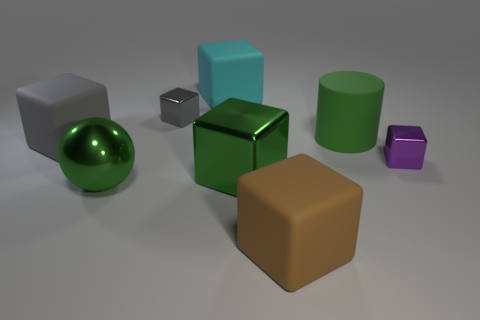Subtract all small purple cubes. How many cubes are left? 5 Add 2 yellow cubes. How many objects exist? 10 Subtract all gray blocks. How many blocks are left? 4 Subtract 4 cubes. How many cubes are left? 2 Subtract all red spheres. How many gray blocks are left? 2 Add 7 shiny balls. How many shiny balls are left? 8 Add 6 small purple metallic blocks. How many small purple metallic blocks exist? 7 Subtract 0 brown cylinders. How many objects are left? 8 Subtract all cylinders. How many objects are left? 7 Subtract all cyan balls. Subtract all blue cylinders. How many balls are left? 1 